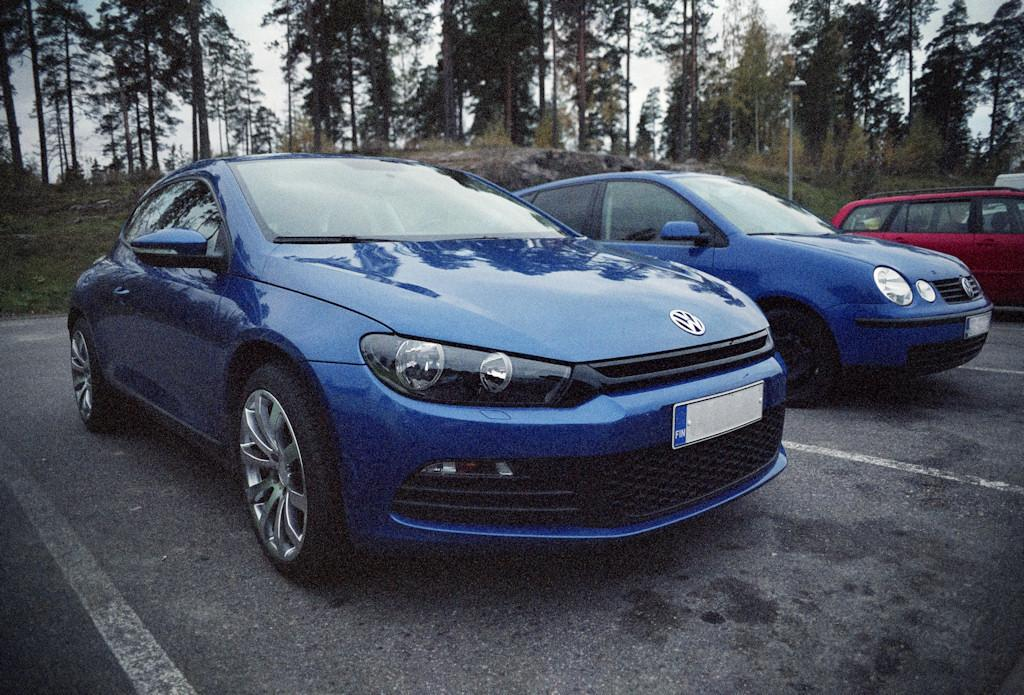What type of vehicles can be seen on the road in the image? There are cars on the road in the image. What else is visible in the image besides the cars? There are lights and trees visible in the image. What can be seen in the background of the image? The sky is visible in the image. Where is the rake being used in the image? There is no rake present in the image. What type of linen is draped over the trees in the image? There is no linen draped over the trees in the image; only cars, lights, trees, and the sky are visible. 